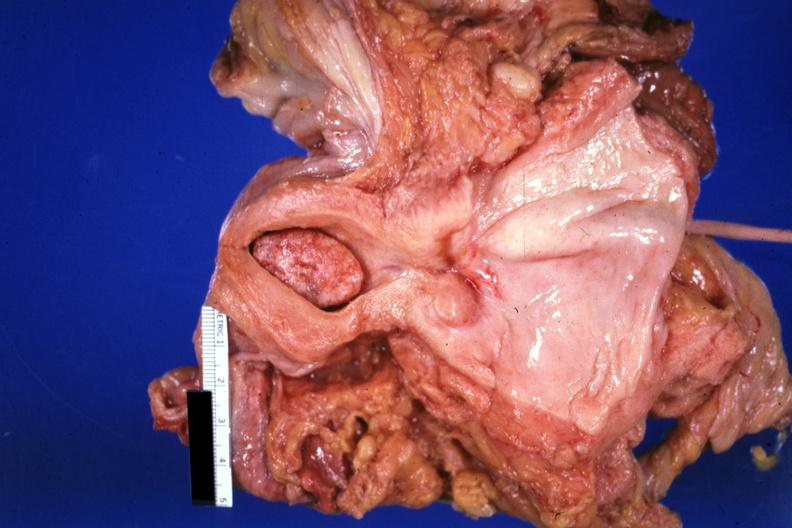s leg present?
Answer the question using a single word or phrase. No 